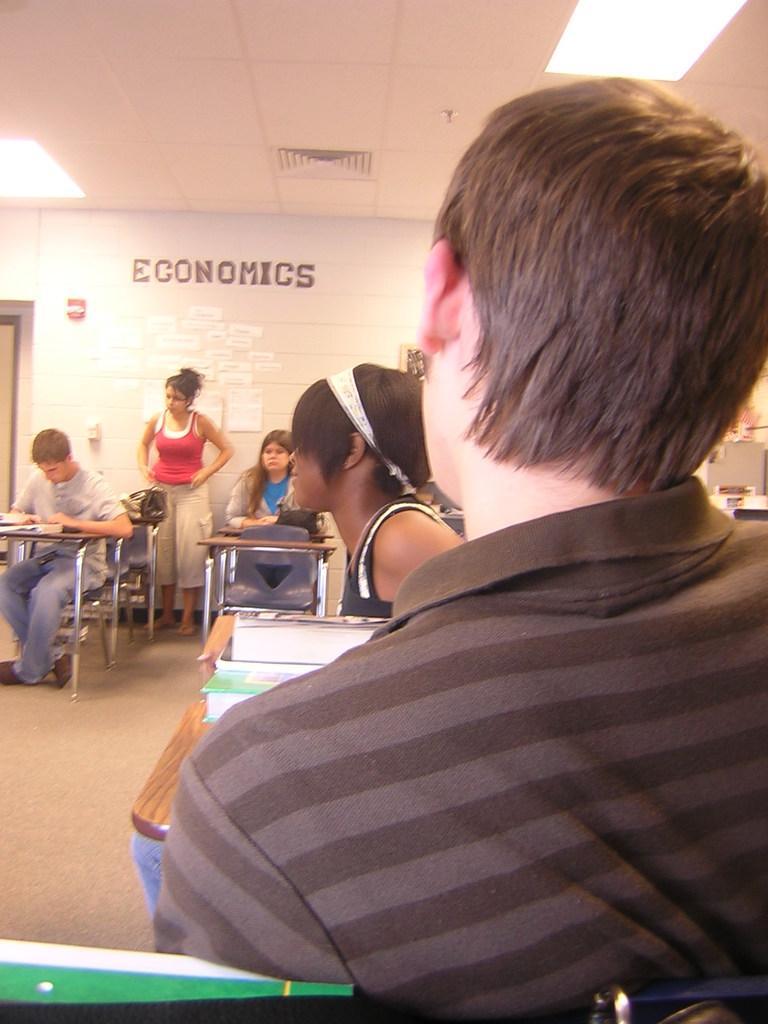How would you summarize this image in a sentence or two? In this picture we can see a group of people where some are sitting on chairs and some are standing and in front of them we can see books and in the background we can see posts on the wall. 